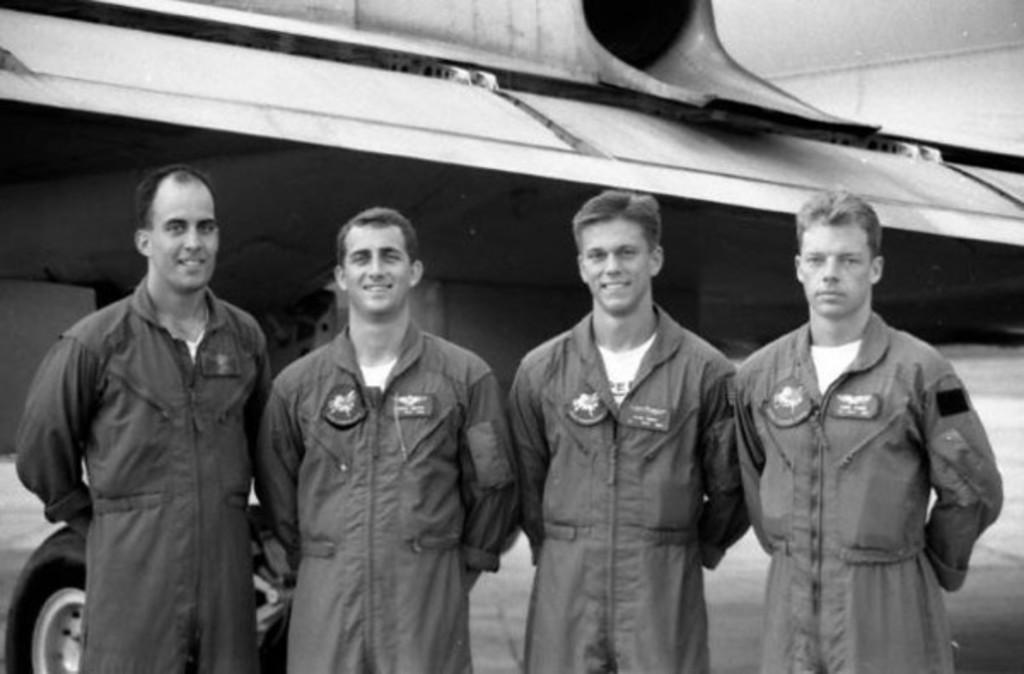What is the color scheme of the image? The image is black and white. What can be seen in the image? There is a group of people standing in the image. What else is visible in the background of the image? There is a part of a plane visible in the background of the image. What historical event is being commemorated by the group of people in the image? There is no indication of a historical event being commemorated in the image. The image is black and white, which could suggest it is an older photograph, but there is no specific historical context provided. 